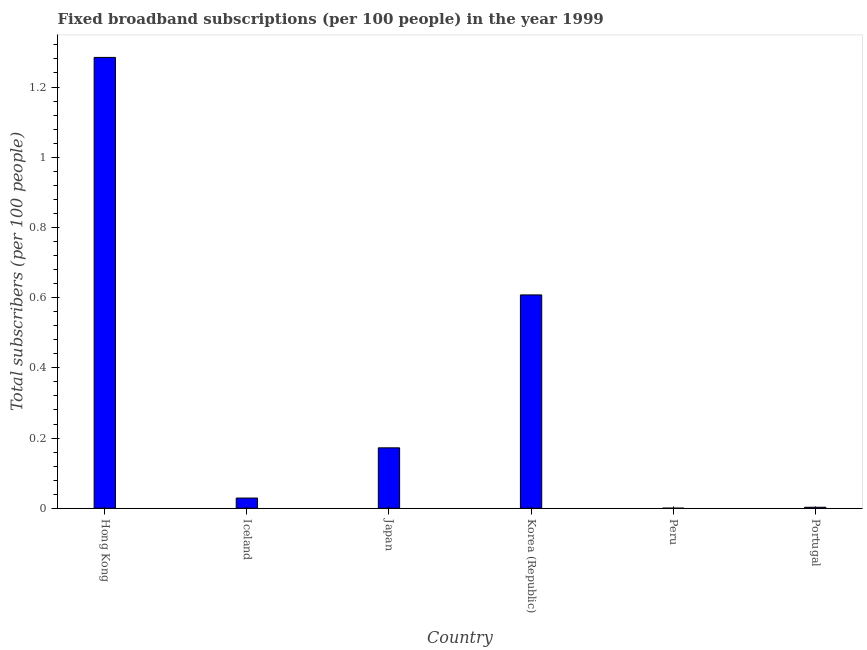What is the title of the graph?
Ensure brevity in your answer.  Fixed broadband subscriptions (per 100 people) in the year 1999. What is the label or title of the Y-axis?
Make the answer very short. Total subscribers (per 100 people). What is the total number of fixed broadband subscriptions in Hong Kong?
Ensure brevity in your answer.  1.28. Across all countries, what is the maximum total number of fixed broadband subscriptions?
Make the answer very short. 1.28. Across all countries, what is the minimum total number of fixed broadband subscriptions?
Keep it short and to the point. 0. In which country was the total number of fixed broadband subscriptions maximum?
Make the answer very short. Hong Kong. In which country was the total number of fixed broadband subscriptions minimum?
Your answer should be very brief. Peru. What is the sum of the total number of fixed broadband subscriptions?
Provide a succinct answer. 2.1. What is the difference between the total number of fixed broadband subscriptions in Japan and Korea (Republic)?
Keep it short and to the point. -0.44. What is the average total number of fixed broadband subscriptions per country?
Keep it short and to the point. 0.35. What is the median total number of fixed broadband subscriptions?
Your response must be concise. 0.1. In how many countries, is the total number of fixed broadband subscriptions greater than 1.04 ?
Offer a very short reply. 1. What is the ratio of the total number of fixed broadband subscriptions in Iceland to that in Japan?
Your response must be concise. 0.17. Is the total number of fixed broadband subscriptions in Hong Kong less than that in Peru?
Provide a short and direct response. No. Is the difference between the total number of fixed broadband subscriptions in Korea (Republic) and Peru greater than the difference between any two countries?
Ensure brevity in your answer.  No. What is the difference between the highest and the second highest total number of fixed broadband subscriptions?
Your answer should be very brief. 0.68. Is the sum of the total number of fixed broadband subscriptions in Iceland and Portugal greater than the maximum total number of fixed broadband subscriptions across all countries?
Your response must be concise. No. What is the difference between the highest and the lowest total number of fixed broadband subscriptions?
Keep it short and to the point. 1.28. In how many countries, is the total number of fixed broadband subscriptions greater than the average total number of fixed broadband subscriptions taken over all countries?
Keep it short and to the point. 2. Are all the bars in the graph horizontal?
Provide a short and direct response. No. How many countries are there in the graph?
Provide a succinct answer. 6. What is the Total subscribers (per 100 people) in Hong Kong?
Provide a short and direct response. 1.28. What is the Total subscribers (per 100 people) in Iceland?
Offer a terse response. 0.03. What is the Total subscribers (per 100 people) in Japan?
Your answer should be compact. 0.17. What is the Total subscribers (per 100 people) of Korea (Republic)?
Make the answer very short. 0.61. What is the Total subscribers (per 100 people) in Peru?
Offer a terse response. 0. What is the Total subscribers (per 100 people) of Portugal?
Provide a short and direct response. 0. What is the difference between the Total subscribers (per 100 people) in Hong Kong and Iceland?
Your response must be concise. 1.26. What is the difference between the Total subscribers (per 100 people) in Hong Kong and Japan?
Your answer should be compact. 1.11. What is the difference between the Total subscribers (per 100 people) in Hong Kong and Korea (Republic)?
Offer a terse response. 0.68. What is the difference between the Total subscribers (per 100 people) in Hong Kong and Peru?
Offer a terse response. 1.28. What is the difference between the Total subscribers (per 100 people) in Hong Kong and Portugal?
Your answer should be compact. 1.28. What is the difference between the Total subscribers (per 100 people) in Iceland and Japan?
Offer a terse response. -0.14. What is the difference between the Total subscribers (per 100 people) in Iceland and Korea (Republic)?
Ensure brevity in your answer.  -0.58. What is the difference between the Total subscribers (per 100 people) in Iceland and Peru?
Ensure brevity in your answer.  0.03. What is the difference between the Total subscribers (per 100 people) in Iceland and Portugal?
Provide a short and direct response. 0.03. What is the difference between the Total subscribers (per 100 people) in Japan and Korea (Republic)?
Your answer should be very brief. -0.44. What is the difference between the Total subscribers (per 100 people) in Japan and Peru?
Offer a very short reply. 0.17. What is the difference between the Total subscribers (per 100 people) in Japan and Portugal?
Your response must be concise. 0.17. What is the difference between the Total subscribers (per 100 people) in Korea (Republic) and Peru?
Provide a succinct answer. 0.61. What is the difference between the Total subscribers (per 100 people) in Korea (Republic) and Portugal?
Provide a short and direct response. 0.6. What is the difference between the Total subscribers (per 100 people) in Peru and Portugal?
Your answer should be very brief. -0. What is the ratio of the Total subscribers (per 100 people) in Hong Kong to that in Iceland?
Make the answer very short. 44.14. What is the ratio of the Total subscribers (per 100 people) in Hong Kong to that in Japan?
Offer a terse response. 7.46. What is the ratio of the Total subscribers (per 100 people) in Hong Kong to that in Korea (Republic)?
Provide a succinct answer. 2.11. What is the ratio of the Total subscribers (per 100 people) in Hong Kong to that in Peru?
Offer a very short reply. 4385.7. What is the ratio of the Total subscribers (per 100 people) in Hong Kong to that in Portugal?
Keep it short and to the point. 443.82. What is the ratio of the Total subscribers (per 100 people) in Iceland to that in Japan?
Your response must be concise. 0.17. What is the ratio of the Total subscribers (per 100 people) in Iceland to that in Korea (Republic)?
Ensure brevity in your answer.  0.05. What is the ratio of the Total subscribers (per 100 people) in Iceland to that in Peru?
Provide a succinct answer. 99.36. What is the ratio of the Total subscribers (per 100 people) in Iceland to that in Portugal?
Offer a terse response. 10.05. What is the ratio of the Total subscribers (per 100 people) in Japan to that in Korea (Republic)?
Offer a very short reply. 0.28. What is the ratio of the Total subscribers (per 100 people) in Japan to that in Peru?
Your answer should be compact. 587.83. What is the ratio of the Total subscribers (per 100 people) in Japan to that in Portugal?
Offer a terse response. 59.49. What is the ratio of the Total subscribers (per 100 people) in Korea (Republic) to that in Peru?
Offer a terse response. 2075.4. What is the ratio of the Total subscribers (per 100 people) in Korea (Republic) to that in Portugal?
Your answer should be very brief. 210.02. What is the ratio of the Total subscribers (per 100 people) in Peru to that in Portugal?
Ensure brevity in your answer.  0.1. 